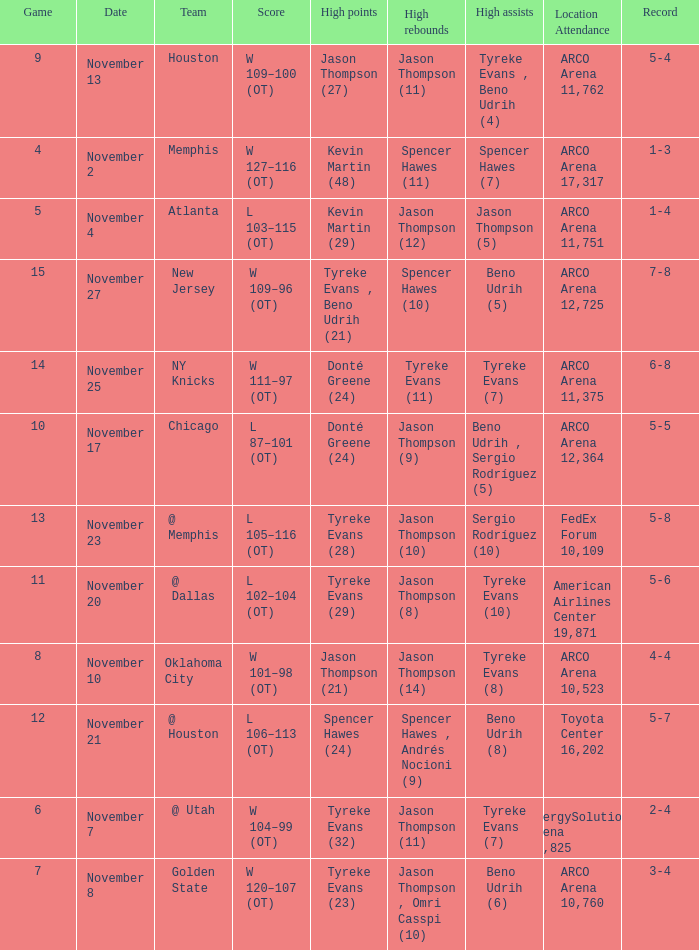If the record is 5-5, what is the game maximum? 10.0. 